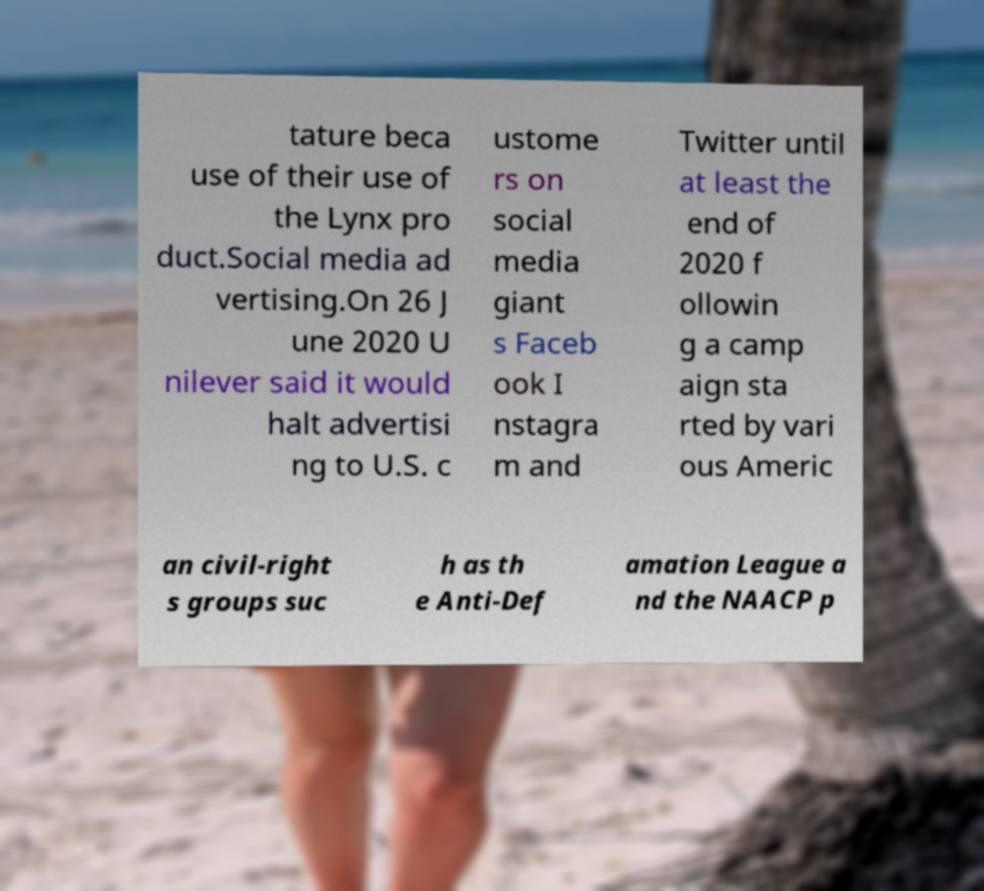Could you assist in decoding the text presented in this image and type it out clearly? tature beca use of their use of the Lynx pro duct.Social media ad vertising.On 26 J une 2020 U nilever said it would halt advertisi ng to U.S. c ustome rs on social media giant s Faceb ook I nstagra m and Twitter until at least the end of 2020 f ollowin g a camp aign sta rted by vari ous Americ an civil-right s groups suc h as th e Anti-Def amation League a nd the NAACP p 